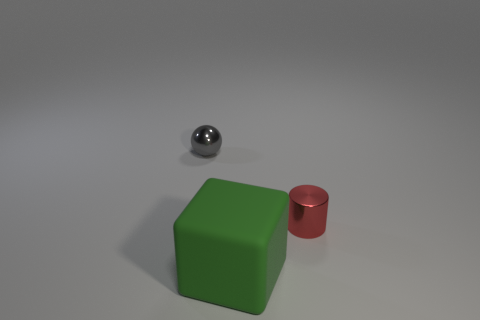Add 1 big green matte spheres. How many objects exist? 4 Subtract all blocks. How many objects are left? 2 Subtract all brown balls. Subtract all large matte things. How many objects are left? 2 Add 3 green rubber things. How many green rubber things are left? 4 Add 1 small purple metal cylinders. How many small purple metal cylinders exist? 1 Subtract 0 blue blocks. How many objects are left? 3 Subtract all purple balls. Subtract all brown blocks. How many balls are left? 1 